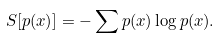Convert formula to latex. <formula><loc_0><loc_0><loc_500><loc_500>S [ p ( x ) ] = - \sum p ( x ) \log p ( x ) .</formula> 